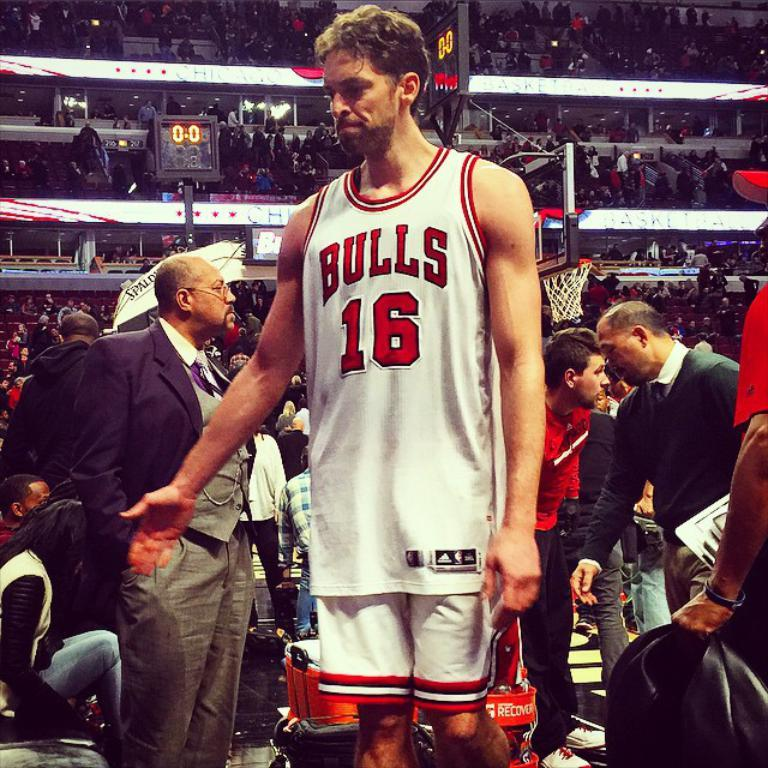<image>
Write a terse but informative summary of the picture. Basketball player for the Chicago Bulls. holding his hand out for a handshake. 